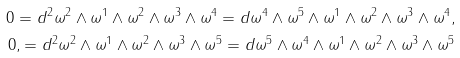<formula> <loc_0><loc_0><loc_500><loc_500>0 = d ^ { 2 } \omega ^ { 2 } \wedge \omega ^ { 1 } \wedge \omega ^ { 2 } \wedge \omega ^ { 3 } \wedge \omega ^ { 4 } = d \omega ^ { 4 } \wedge \omega ^ { 5 } \wedge \omega ^ { 1 } \wedge \omega ^ { 2 } \wedge \omega ^ { 3 } \wedge \omega ^ { 4 } , \\ 0 , = d ^ { 2 } \omega ^ { 2 } \wedge \omega ^ { 1 } \wedge \omega ^ { 2 } \wedge \omega ^ { 3 } \wedge \omega ^ { 5 } = d \omega ^ { 5 } \wedge \omega ^ { 4 } \wedge \omega ^ { 1 } \wedge \omega ^ { 2 } \wedge \omega ^ { 3 } \wedge \omega ^ { 5 }</formula> 